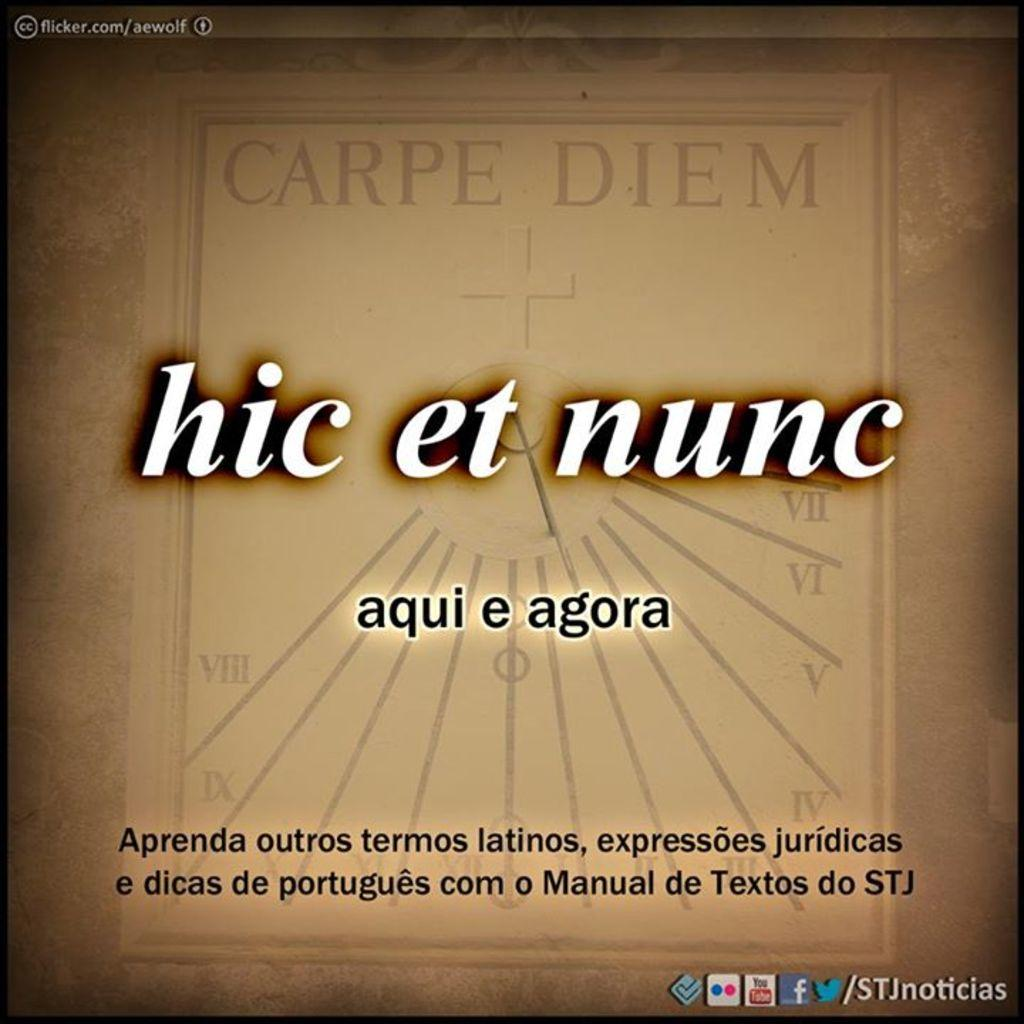Provide a one-sentence caption for the provided image. Carpe Diem and hic et nunc are written on a tan background with other spanish words. 